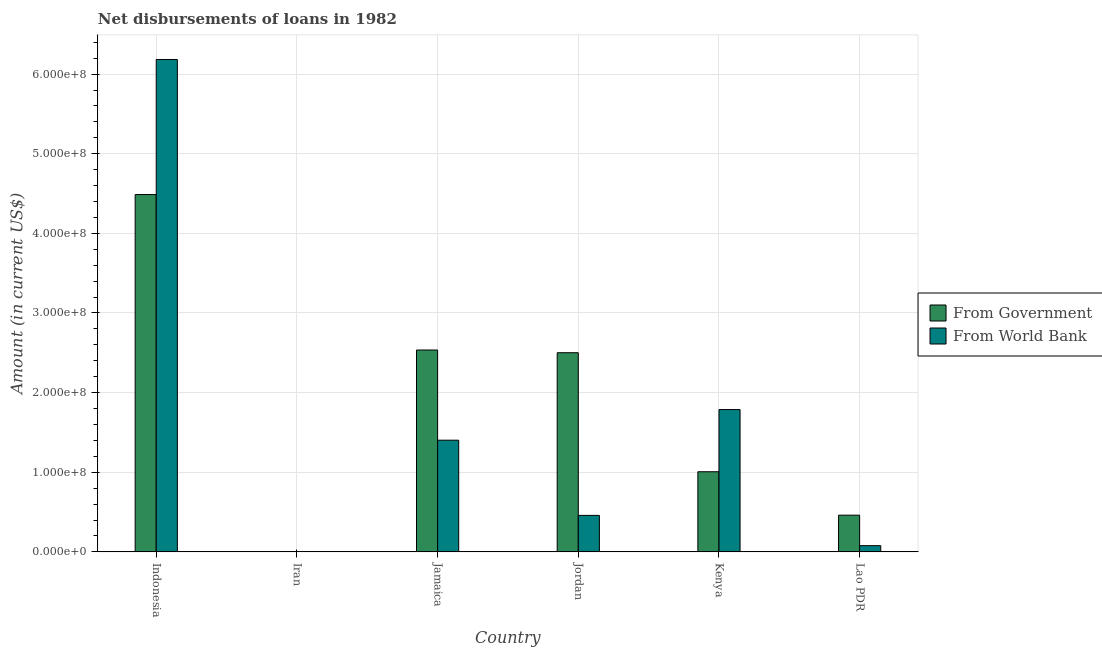How many different coloured bars are there?
Give a very brief answer. 2. How many bars are there on the 4th tick from the left?
Ensure brevity in your answer.  2. What is the label of the 6th group of bars from the left?
Provide a succinct answer. Lao PDR. In how many cases, is the number of bars for a given country not equal to the number of legend labels?
Provide a short and direct response. 1. What is the net disbursements of loan from world bank in Indonesia?
Your response must be concise. 6.18e+08. Across all countries, what is the maximum net disbursements of loan from government?
Keep it short and to the point. 4.49e+08. Across all countries, what is the minimum net disbursements of loan from government?
Ensure brevity in your answer.  0. What is the total net disbursements of loan from government in the graph?
Offer a terse response. 1.10e+09. What is the difference between the net disbursements of loan from world bank in Indonesia and that in Kenya?
Offer a very short reply. 4.40e+08. What is the difference between the net disbursements of loan from government in Lao PDR and the net disbursements of loan from world bank in Jamaica?
Give a very brief answer. -9.42e+07. What is the average net disbursements of loan from government per country?
Give a very brief answer. 1.83e+08. What is the difference between the net disbursements of loan from government and net disbursements of loan from world bank in Jamaica?
Give a very brief answer. 1.13e+08. What is the ratio of the net disbursements of loan from world bank in Jordan to that in Lao PDR?
Provide a succinct answer. 5.88. Is the net disbursements of loan from government in Indonesia less than that in Jordan?
Your response must be concise. No. What is the difference between the highest and the second highest net disbursements of loan from world bank?
Provide a succinct answer. 4.40e+08. What is the difference between the highest and the lowest net disbursements of loan from government?
Provide a succinct answer. 4.49e+08. In how many countries, is the net disbursements of loan from world bank greater than the average net disbursements of loan from world bank taken over all countries?
Provide a succinct answer. 2. How many bars are there?
Your response must be concise. 10. Are all the bars in the graph horizontal?
Your answer should be very brief. No. How many countries are there in the graph?
Provide a short and direct response. 6. What is the difference between two consecutive major ticks on the Y-axis?
Offer a very short reply. 1.00e+08. Are the values on the major ticks of Y-axis written in scientific E-notation?
Provide a succinct answer. Yes. Does the graph contain any zero values?
Offer a very short reply. Yes. Where does the legend appear in the graph?
Your answer should be compact. Center right. How many legend labels are there?
Keep it short and to the point. 2. How are the legend labels stacked?
Your answer should be very brief. Vertical. What is the title of the graph?
Provide a succinct answer. Net disbursements of loans in 1982. Does "Quasi money growth" appear as one of the legend labels in the graph?
Keep it short and to the point. No. What is the label or title of the X-axis?
Provide a short and direct response. Country. What is the Amount (in current US$) of From Government in Indonesia?
Make the answer very short. 4.49e+08. What is the Amount (in current US$) in From World Bank in Indonesia?
Keep it short and to the point. 6.18e+08. What is the Amount (in current US$) in From Government in Iran?
Your answer should be very brief. 0. What is the Amount (in current US$) in From Government in Jamaica?
Provide a short and direct response. 2.54e+08. What is the Amount (in current US$) in From World Bank in Jamaica?
Give a very brief answer. 1.40e+08. What is the Amount (in current US$) in From Government in Jordan?
Offer a terse response. 2.50e+08. What is the Amount (in current US$) of From World Bank in Jordan?
Your answer should be very brief. 4.58e+07. What is the Amount (in current US$) of From Government in Kenya?
Ensure brevity in your answer.  1.01e+08. What is the Amount (in current US$) in From World Bank in Kenya?
Offer a terse response. 1.79e+08. What is the Amount (in current US$) of From Government in Lao PDR?
Your answer should be compact. 4.61e+07. What is the Amount (in current US$) in From World Bank in Lao PDR?
Your answer should be compact. 7.80e+06. Across all countries, what is the maximum Amount (in current US$) in From Government?
Your response must be concise. 4.49e+08. Across all countries, what is the maximum Amount (in current US$) in From World Bank?
Provide a succinct answer. 6.18e+08. Across all countries, what is the minimum Amount (in current US$) of From World Bank?
Offer a very short reply. 0. What is the total Amount (in current US$) in From Government in the graph?
Offer a very short reply. 1.10e+09. What is the total Amount (in current US$) of From World Bank in the graph?
Your answer should be very brief. 9.91e+08. What is the difference between the Amount (in current US$) in From Government in Indonesia and that in Jamaica?
Make the answer very short. 1.95e+08. What is the difference between the Amount (in current US$) of From World Bank in Indonesia and that in Jamaica?
Your answer should be compact. 4.78e+08. What is the difference between the Amount (in current US$) of From Government in Indonesia and that in Jordan?
Offer a terse response. 1.99e+08. What is the difference between the Amount (in current US$) in From World Bank in Indonesia and that in Jordan?
Offer a very short reply. 5.73e+08. What is the difference between the Amount (in current US$) of From Government in Indonesia and that in Kenya?
Keep it short and to the point. 3.48e+08. What is the difference between the Amount (in current US$) in From World Bank in Indonesia and that in Kenya?
Give a very brief answer. 4.40e+08. What is the difference between the Amount (in current US$) of From Government in Indonesia and that in Lao PDR?
Offer a terse response. 4.03e+08. What is the difference between the Amount (in current US$) in From World Bank in Indonesia and that in Lao PDR?
Ensure brevity in your answer.  6.11e+08. What is the difference between the Amount (in current US$) of From Government in Jamaica and that in Jordan?
Provide a succinct answer. 3.41e+06. What is the difference between the Amount (in current US$) of From World Bank in Jamaica and that in Jordan?
Your response must be concise. 9.44e+07. What is the difference between the Amount (in current US$) in From Government in Jamaica and that in Kenya?
Your answer should be compact. 1.53e+08. What is the difference between the Amount (in current US$) in From World Bank in Jamaica and that in Kenya?
Your answer should be compact. -3.85e+07. What is the difference between the Amount (in current US$) in From Government in Jamaica and that in Lao PDR?
Your answer should be compact. 2.07e+08. What is the difference between the Amount (in current US$) in From World Bank in Jamaica and that in Lao PDR?
Offer a very short reply. 1.32e+08. What is the difference between the Amount (in current US$) in From Government in Jordan and that in Kenya?
Provide a succinct answer. 1.49e+08. What is the difference between the Amount (in current US$) of From World Bank in Jordan and that in Kenya?
Your response must be concise. -1.33e+08. What is the difference between the Amount (in current US$) in From Government in Jordan and that in Lao PDR?
Provide a succinct answer. 2.04e+08. What is the difference between the Amount (in current US$) of From World Bank in Jordan and that in Lao PDR?
Provide a succinct answer. 3.80e+07. What is the difference between the Amount (in current US$) in From Government in Kenya and that in Lao PDR?
Provide a short and direct response. 5.45e+07. What is the difference between the Amount (in current US$) of From World Bank in Kenya and that in Lao PDR?
Provide a short and direct response. 1.71e+08. What is the difference between the Amount (in current US$) of From Government in Indonesia and the Amount (in current US$) of From World Bank in Jamaica?
Provide a succinct answer. 3.08e+08. What is the difference between the Amount (in current US$) of From Government in Indonesia and the Amount (in current US$) of From World Bank in Jordan?
Make the answer very short. 4.03e+08. What is the difference between the Amount (in current US$) of From Government in Indonesia and the Amount (in current US$) of From World Bank in Kenya?
Ensure brevity in your answer.  2.70e+08. What is the difference between the Amount (in current US$) of From Government in Indonesia and the Amount (in current US$) of From World Bank in Lao PDR?
Provide a succinct answer. 4.41e+08. What is the difference between the Amount (in current US$) in From Government in Jamaica and the Amount (in current US$) in From World Bank in Jordan?
Provide a succinct answer. 2.08e+08. What is the difference between the Amount (in current US$) in From Government in Jamaica and the Amount (in current US$) in From World Bank in Kenya?
Your answer should be very brief. 7.48e+07. What is the difference between the Amount (in current US$) in From Government in Jamaica and the Amount (in current US$) in From World Bank in Lao PDR?
Offer a terse response. 2.46e+08. What is the difference between the Amount (in current US$) in From Government in Jordan and the Amount (in current US$) in From World Bank in Kenya?
Keep it short and to the point. 7.14e+07. What is the difference between the Amount (in current US$) of From Government in Jordan and the Amount (in current US$) of From World Bank in Lao PDR?
Make the answer very short. 2.42e+08. What is the difference between the Amount (in current US$) in From Government in Kenya and the Amount (in current US$) in From World Bank in Lao PDR?
Your answer should be compact. 9.28e+07. What is the average Amount (in current US$) of From Government per country?
Your answer should be very brief. 1.83e+08. What is the average Amount (in current US$) in From World Bank per country?
Keep it short and to the point. 1.65e+08. What is the difference between the Amount (in current US$) of From Government and Amount (in current US$) of From World Bank in Indonesia?
Your answer should be compact. -1.70e+08. What is the difference between the Amount (in current US$) in From Government and Amount (in current US$) in From World Bank in Jamaica?
Keep it short and to the point. 1.13e+08. What is the difference between the Amount (in current US$) in From Government and Amount (in current US$) in From World Bank in Jordan?
Offer a very short reply. 2.04e+08. What is the difference between the Amount (in current US$) in From Government and Amount (in current US$) in From World Bank in Kenya?
Offer a very short reply. -7.81e+07. What is the difference between the Amount (in current US$) in From Government and Amount (in current US$) in From World Bank in Lao PDR?
Your response must be concise. 3.83e+07. What is the ratio of the Amount (in current US$) in From Government in Indonesia to that in Jamaica?
Give a very brief answer. 1.77. What is the ratio of the Amount (in current US$) of From World Bank in Indonesia to that in Jamaica?
Your answer should be compact. 4.41. What is the ratio of the Amount (in current US$) in From Government in Indonesia to that in Jordan?
Make the answer very short. 1.79. What is the ratio of the Amount (in current US$) of From World Bank in Indonesia to that in Jordan?
Give a very brief answer. 13.49. What is the ratio of the Amount (in current US$) in From Government in Indonesia to that in Kenya?
Keep it short and to the point. 4.46. What is the ratio of the Amount (in current US$) in From World Bank in Indonesia to that in Kenya?
Provide a short and direct response. 3.46. What is the ratio of the Amount (in current US$) in From Government in Indonesia to that in Lao PDR?
Your answer should be compact. 9.74. What is the ratio of the Amount (in current US$) in From World Bank in Indonesia to that in Lao PDR?
Your response must be concise. 79.28. What is the ratio of the Amount (in current US$) of From Government in Jamaica to that in Jordan?
Keep it short and to the point. 1.01. What is the ratio of the Amount (in current US$) of From World Bank in Jamaica to that in Jordan?
Your answer should be very brief. 3.06. What is the ratio of the Amount (in current US$) in From Government in Jamaica to that in Kenya?
Ensure brevity in your answer.  2.52. What is the ratio of the Amount (in current US$) of From World Bank in Jamaica to that in Kenya?
Provide a succinct answer. 0.78. What is the ratio of the Amount (in current US$) of From Government in Jamaica to that in Lao PDR?
Keep it short and to the point. 5.5. What is the ratio of the Amount (in current US$) in From World Bank in Jamaica to that in Lao PDR?
Your answer should be compact. 17.98. What is the ratio of the Amount (in current US$) in From Government in Jordan to that in Kenya?
Your response must be concise. 2.49. What is the ratio of the Amount (in current US$) in From World Bank in Jordan to that in Kenya?
Your response must be concise. 0.26. What is the ratio of the Amount (in current US$) of From Government in Jordan to that in Lao PDR?
Your response must be concise. 5.43. What is the ratio of the Amount (in current US$) in From World Bank in Jordan to that in Lao PDR?
Your response must be concise. 5.88. What is the ratio of the Amount (in current US$) of From Government in Kenya to that in Lao PDR?
Offer a terse response. 2.18. What is the ratio of the Amount (in current US$) of From World Bank in Kenya to that in Lao PDR?
Keep it short and to the point. 22.91. What is the difference between the highest and the second highest Amount (in current US$) in From Government?
Your response must be concise. 1.95e+08. What is the difference between the highest and the second highest Amount (in current US$) of From World Bank?
Offer a very short reply. 4.40e+08. What is the difference between the highest and the lowest Amount (in current US$) of From Government?
Offer a very short reply. 4.49e+08. What is the difference between the highest and the lowest Amount (in current US$) of From World Bank?
Offer a terse response. 6.18e+08. 